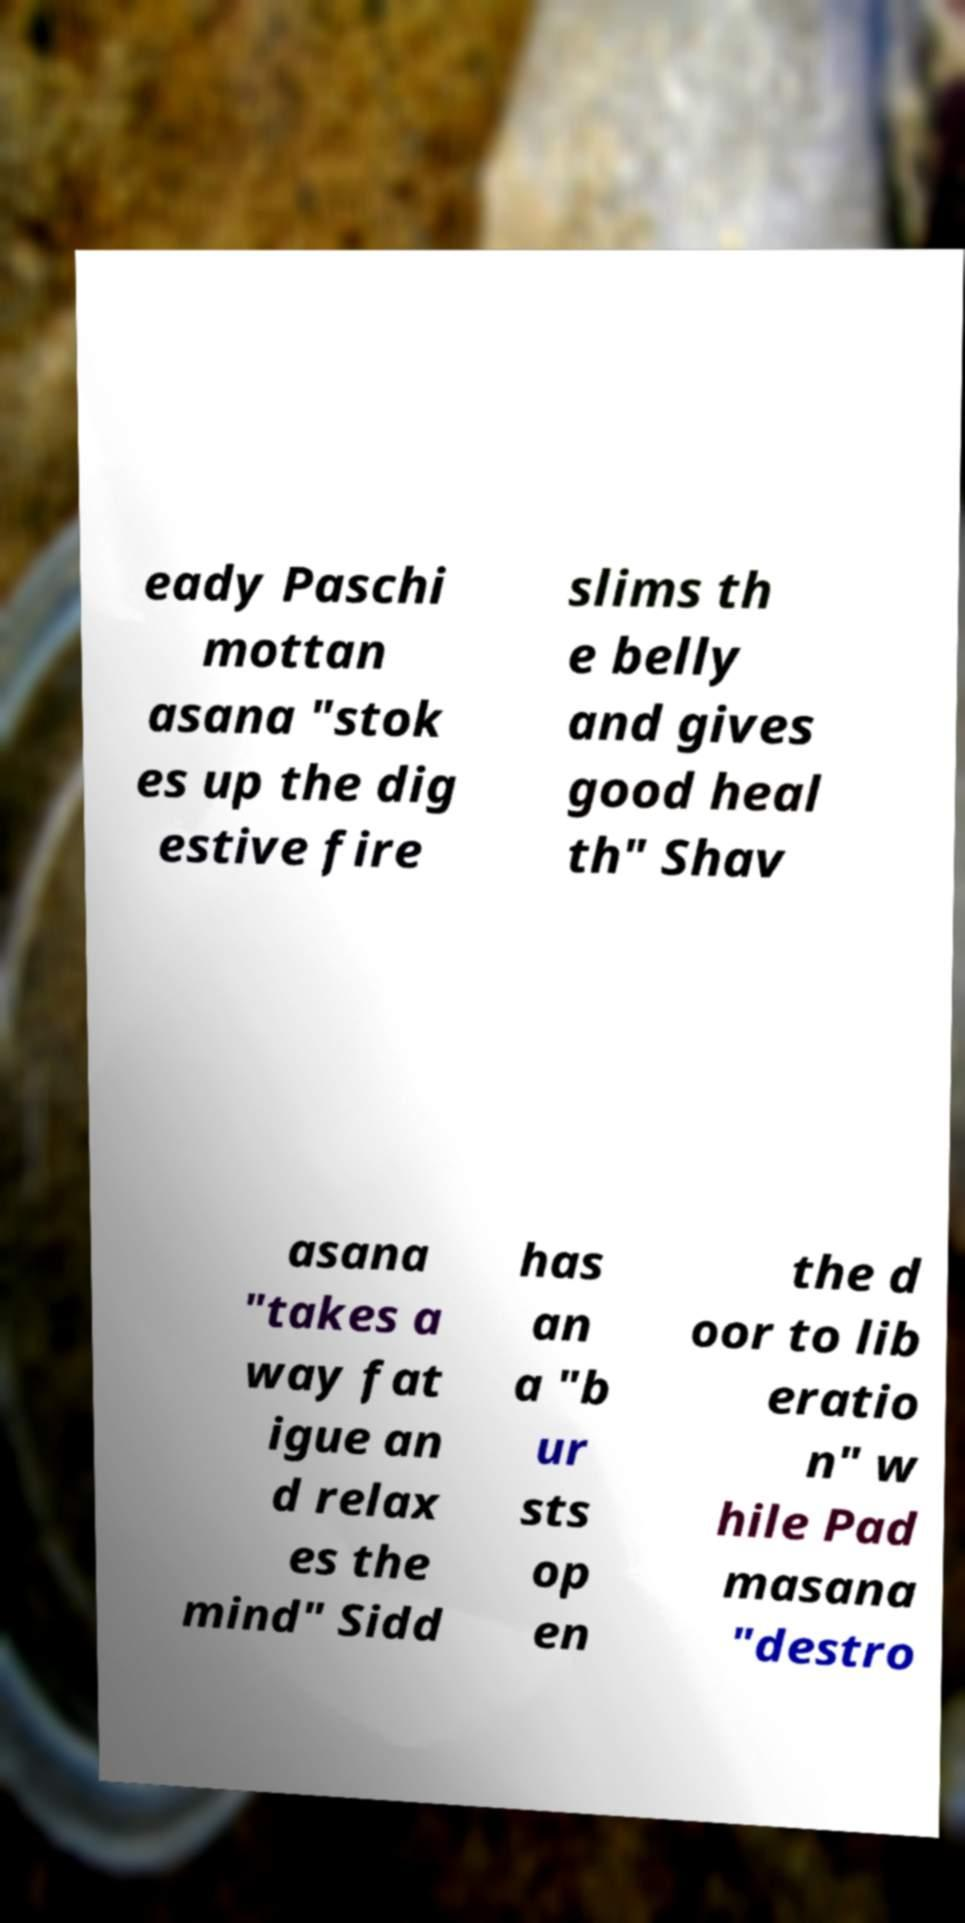Could you extract and type out the text from this image? eady Paschi mottan asana "stok es up the dig estive fire slims th e belly and gives good heal th" Shav asana "takes a way fat igue an d relax es the mind" Sidd has an a "b ur sts op en the d oor to lib eratio n" w hile Pad masana "destro 